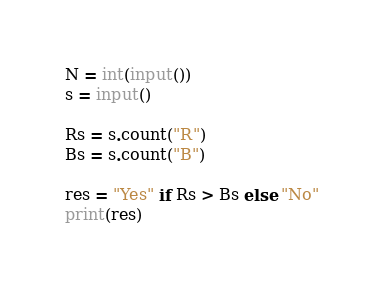Convert code to text. <code><loc_0><loc_0><loc_500><loc_500><_Python_>N = int(input())
s = input()

Rs = s.count("R")
Bs = s.count("B")

res = "Yes" if Rs > Bs else "No"
print(res)
</code> 